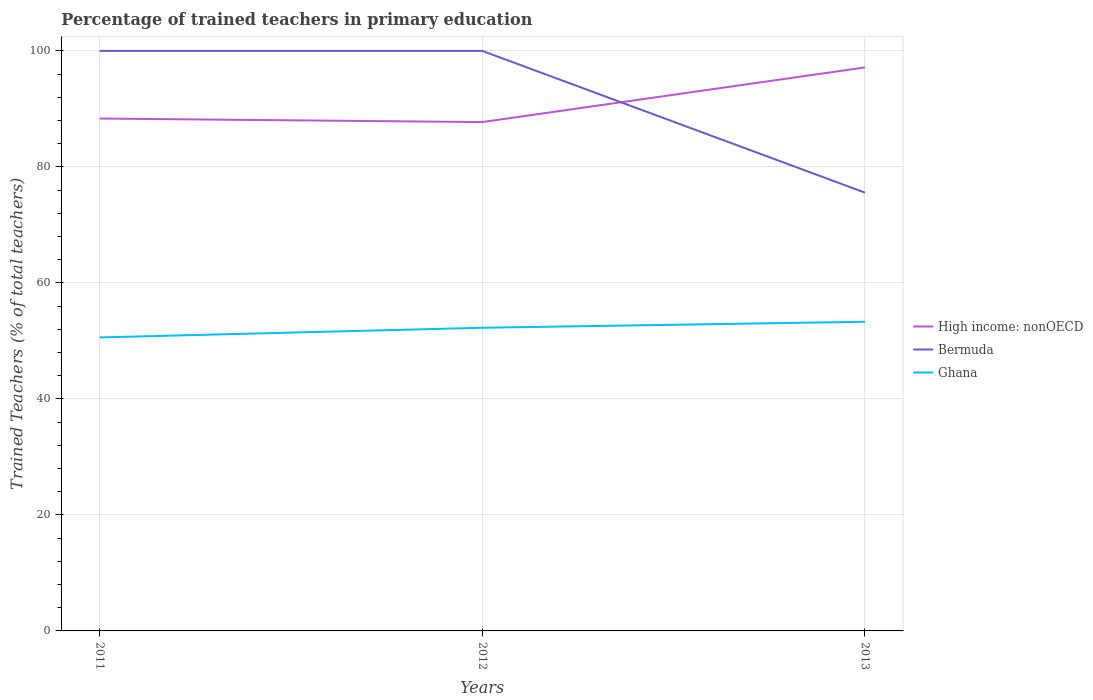Does the line corresponding to Bermuda intersect with the line corresponding to High income: nonOECD?
Keep it short and to the point. Yes. Is the number of lines equal to the number of legend labels?
Your answer should be very brief. Yes. Across all years, what is the maximum percentage of trained teachers in Ghana?
Your answer should be compact. 50.6. In which year was the percentage of trained teachers in High income: nonOECD maximum?
Make the answer very short. 2012. What is the total percentage of trained teachers in High income: nonOECD in the graph?
Offer a very short reply. -9.42. What is the difference between the highest and the second highest percentage of trained teachers in Bermuda?
Offer a terse response. 24.43. What is the difference between the highest and the lowest percentage of trained teachers in Bermuda?
Your answer should be compact. 2. How many lines are there?
Your answer should be compact. 3. How many years are there in the graph?
Give a very brief answer. 3. Are the values on the major ticks of Y-axis written in scientific E-notation?
Provide a short and direct response. No. Does the graph contain any zero values?
Make the answer very short. No. What is the title of the graph?
Make the answer very short. Percentage of trained teachers in primary education. Does "Aruba" appear as one of the legend labels in the graph?
Your answer should be very brief. No. What is the label or title of the Y-axis?
Offer a very short reply. Trained Teachers (% of total teachers). What is the Trained Teachers (% of total teachers) of High income: nonOECD in 2011?
Your response must be concise. 88.34. What is the Trained Teachers (% of total teachers) in Bermuda in 2011?
Ensure brevity in your answer.  100. What is the Trained Teachers (% of total teachers) in Ghana in 2011?
Keep it short and to the point. 50.6. What is the Trained Teachers (% of total teachers) in High income: nonOECD in 2012?
Your answer should be compact. 87.73. What is the Trained Teachers (% of total teachers) of Bermuda in 2012?
Provide a short and direct response. 100. What is the Trained Teachers (% of total teachers) of Ghana in 2012?
Your answer should be compact. 52.27. What is the Trained Teachers (% of total teachers) in High income: nonOECD in 2013?
Keep it short and to the point. 97.15. What is the Trained Teachers (% of total teachers) of Bermuda in 2013?
Your answer should be compact. 75.57. What is the Trained Teachers (% of total teachers) in Ghana in 2013?
Your answer should be very brief. 53.3. Across all years, what is the maximum Trained Teachers (% of total teachers) of High income: nonOECD?
Make the answer very short. 97.15. Across all years, what is the maximum Trained Teachers (% of total teachers) in Ghana?
Your response must be concise. 53.3. Across all years, what is the minimum Trained Teachers (% of total teachers) in High income: nonOECD?
Make the answer very short. 87.73. Across all years, what is the minimum Trained Teachers (% of total teachers) of Bermuda?
Your answer should be compact. 75.57. Across all years, what is the minimum Trained Teachers (% of total teachers) of Ghana?
Offer a very short reply. 50.6. What is the total Trained Teachers (% of total teachers) in High income: nonOECD in the graph?
Offer a terse response. 273.22. What is the total Trained Teachers (% of total teachers) in Bermuda in the graph?
Provide a succinct answer. 275.57. What is the total Trained Teachers (% of total teachers) of Ghana in the graph?
Your answer should be compact. 156.17. What is the difference between the Trained Teachers (% of total teachers) of High income: nonOECD in 2011 and that in 2012?
Provide a short and direct response. 0.61. What is the difference between the Trained Teachers (% of total teachers) of Ghana in 2011 and that in 2012?
Your answer should be very brief. -1.67. What is the difference between the Trained Teachers (% of total teachers) in High income: nonOECD in 2011 and that in 2013?
Your answer should be compact. -8.81. What is the difference between the Trained Teachers (% of total teachers) of Bermuda in 2011 and that in 2013?
Give a very brief answer. 24.43. What is the difference between the Trained Teachers (% of total teachers) of Ghana in 2011 and that in 2013?
Offer a very short reply. -2.7. What is the difference between the Trained Teachers (% of total teachers) in High income: nonOECD in 2012 and that in 2013?
Offer a terse response. -9.42. What is the difference between the Trained Teachers (% of total teachers) in Bermuda in 2012 and that in 2013?
Give a very brief answer. 24.43. What is the difference between the Trained Teachers (% of total teachers) of Ghana in 2012 and that in 2013?
Your answer should be very brief. -1.04. What is the difference between the Trained Teachers (% of total teachers) in High income: nonOECD in 2011 and the Trained Teachers (% of total teachers) in Bermuda in 2012?
Provide a short and direct response. -11.66. What is the difference between the Trained Teachers (% of total teachers) in High income: nonOECD in 2011 and the Trained Teachers (% of total teachers) in Ghana in 2012?
Your answer should be very brief. 36.07. What is the difference between the Trained Teachers (% of total teachers) in Bermuda in 2011 and the Trained Teachers (% of total teachers) in Ghana in 2012?
Give a very brief answer. 47.73. What is the difference between the Trained Teachers (% of total teachers) in High income: nonOECD in 2011 and the Trained Teachers (% of total teachers) in Bermuda in 2013?
Ensure brevity in your answer.  12.77. What is the difference between the Trained Teachers (% of total teachers) of High income: nonOECD in 2011 and the Trained Teachers (% of total teachers) of Ghana in 2013?
Your response must be concise. 35.04. What is the difference between the Trained Teachers (% of total teachers) of Bermuda in 2011 and the Trained Teachers (% of total teachers) of Ghana in 2013?
Provide a short and direct response. 46.7. What is the difference between the Trained Teachers (% of total teachers) of High income: nonOECD in 2012 and the Trained Teachers (% of total teachers) of Bermuda in 2013?
Your response must be concise. 12.16. What is the difference between the Trained Teachers (% of total teachers) in High income: nonOECD in 2012 and the Trained Teachers (% of total teachers) in Ghana in 2013?
Provide a succinct answer. 34.43. What is the difference between the Trained Teachers (% of total teachers) in Bermuda in 2012 and the Trained Teachers (% of total teachers) in Ghana in 2013?
Provide a short and direct response. 46.7. What is the average Trained Teachers (% of total teachers) in High income: nonOECD per year?
Provide a short and direct response. 91.07. What is the average Trained Teachers (% of total teachers) in Bermuda per year?
Make the answer very short. 91.86. What is the average Trained Teachers (% of total teachers) in Ghana per year?
Provide a succinct answer. 52.06. In the year 2011, what is the difference between the Trained Teachers (% of total teachers) in High income: nonOECD and Trained Teachers (% of total teachers) in Bermuda?
Make the answer very short. -11.66. In the year 2011, what is the difference between the Trained Teachers (% of total teachers) of High income: nonOECD and Trained Teachers (% of total teachers) of Ghana?
Provide a short and direct response. 37.74. In the year 2011, what is the difference between the Trained Teachers (% of total teachers) of Bermuda and Trained Teachers (% of total teachers) of Ghana?
Offer a very short reply. 49.4. In the year 2012, what is the difference between the Trained Teachers (% of total teachers) of High income: nonOECD and Trained Teachers (% of total teachers) of Bermuda?
Your answer should be very brief. -12.27. In the year 2012, what is the difference between the Trained Teachers (% of total teachers) in High income: nonOECD and Trained Teachers (% of total teachers) in Ghana?
Give a very brief answer. 35.46. In the year 2012, what is the difference between the Trained Teachers (% of total teachers) in Bermuda and Trained Teachers (% of total teachers) in Ghana?
Your response must be concise. 47.73. In the year 2013, what is the difference between the Trained Teachers (% of total teachers) of High income: nonOECD and Trained Teachers (% of total teachers) of Bermuda?
Give a very brief answer. 21.58. In the year 2013, what is the difference between the Trained Teachers (% of total teachers) of High income: nonOECD and Trained Teachers (% of total teachers) of Ghana?
Provide a succinct answer. 43.84. In the year 2013, what is the difference between the Trained Teachers (% of total teachers) of Bermuda and Trained Teachers (% of total teachers) of Ghana?
Your answer should be compact. 22.26. What is the ratio of the Trained Teachers (% of total teachers) in Ghana in 2011 to that in 2012?
Your answer should be compact. 0.97. What is the ratio of the Trained Teachers (% of total teachers) in High income: nonOECD in 2011 to that in 2013?
Your answer should be compact. 0.91. What is the ratio of the Trained Teachers (% of total teachers) in Bermuda in 2011 to that in 2013?
Provide a short and direct response. 1.32. What is the ratio of the Trained Teachers (% of total teachers) of Ghana in 2011 to that in 2013?
Provide a short and direct response. 0.95. What is the ratio of the Trained Teachers (% of total teachers) in High income: nonOECD in 2012 to that in 2013?
Provide a short and direct response. 0.9. What is the ratio of the Trained Teachers (% of total teachers) of Bermuda in 2012 to that in 2013?
Offer a terse response. 1.32. What is the ratio of the Trained Teachers (% of total teachers) of Ghana in 2012 to that in 2013?
Offer a very short reply. 0.98. What is the difference between the highest and the second highest Trained Teachers (% of total teachers) in High income: nonOECD?
Your response must be concise. 8.81. What is the difference between the highest and the second highest Trained Teachers (% of total teachers) in Ghana?
Offer a very short reply. 1.04. What is the difference between the highest and the lowest Trained Teachers (% of total teachers) in High income: nonOECD?
Provide a short and direct response. 9.42. What is the difference between the highest and the lowest Trained Teachers (% of total teachers) of Bermuda?
Provide a succinct answer. 24.43. What is the difference between the highest and the lowest Trained Teachers (% of total teachers) in Ghana?
Offer a very short reply. 2.7. 